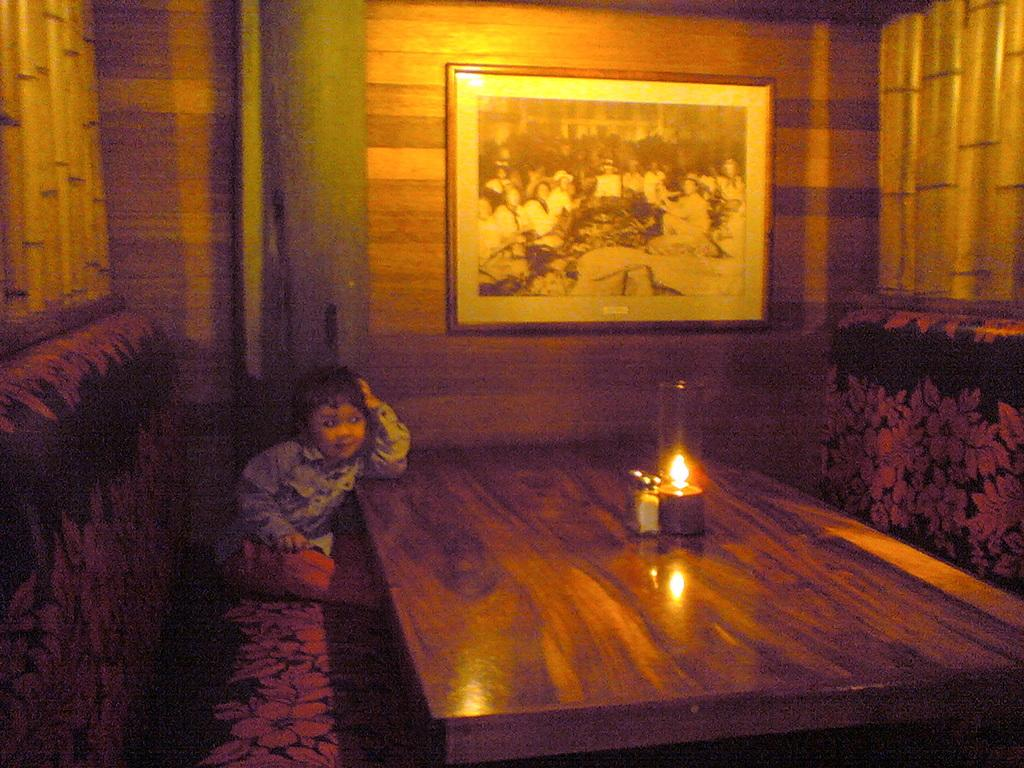What is the child doing in the image? The child is sitting in the image. What is the child wearing? The child is wearing clothes. What type of furniture is present in the image? There is a wooden table, a lamp, a frame on the wall, and a sofa in the image. How many pets are visible in the image? There are no pets visible in the image. What time of day is it in the image, based on the hour shown on the clock? There is no clock present in the image, so we cannot determine the time of day. 